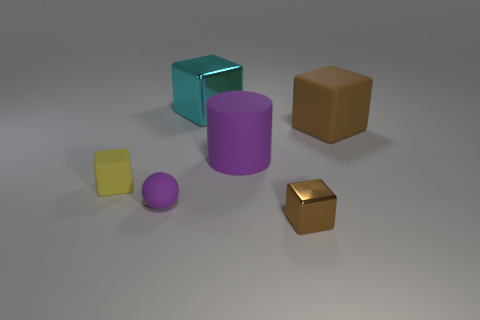Is the material of the small purple ball the same as the large thing right of the rubber cylinder?
Your answer should be very brief. Yes. Is the shape of the tiny purple rubber object the same as the yellow object?
Your response must be concise. No. What material is the other big thing that is the same shape as the cyan metallic thing?
Provide a succinct answer. Rubber. There is a matte object that is both in front of the cylinder and right of the small yellow object; what is its color?
Offer a terse response. Purple. What is the color of the large rubber cylinder?
Your answer should be compact. Purple. There is a object that is the same color as the big cylinder; what is its material?
Your answer should be very brief. Rubber. Is there another rubber thing that has the same shape as the large cyan object?
Keep it short and to the point. Yes. There is a metallic block that is behind the ball; how big is it?
Ensure brevity in your answer.  Large. There is a brown object that is the same size as the ball; what material is it?
Your answer should be very brief. Metal. Are there more matte things than purple metallic things?
Keep it short and to the point. Yes. 